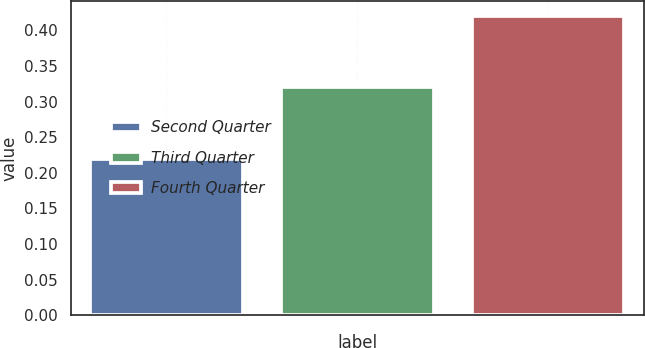Convert chart. <chart><loc_0><loc_0><loc_500><loc_500><bar_chart><fcel>Second Quarter<fcel>Third Quarter<fcel>Fourth Quarter<nl><fcel>0.22<fcel>0.32<fcel>0.42<nl></chart> 